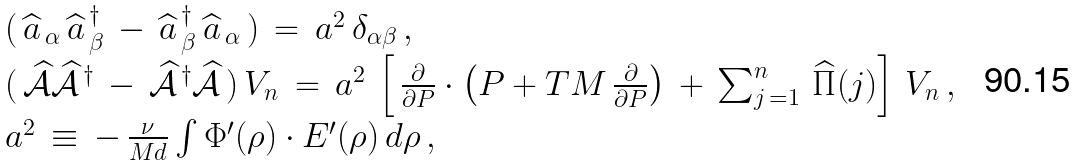Convert formula to latex. <formula><loc_0><loc_0><loc_500><loc_500>\begin{array} { l } ( \, \widehat { a } _ { \, \alpha } \, \widehat { a } ^ { \, \dag } _ { \, \beta } \, - \, \widehat { a } ^ { \, \dag } _ { \, \beta } \, \widehat { a } _ { \, \alpha } \, ) \, = \, a ^ { 2 } \, \delta _ { \alpha \beta } \, , \\ ( \, \widehat { \mathcal { A } } \widehat { \mathcal { A } } ^ { \, \dag } \, - \, \widehat { \mathcal { A } } ^ { \, \dag } \widehat { \mathcal { A } } \, ) \, V _ { n } \, = \, a ^ { 2 } \, \left [ \, \frac { \partial } { \partial { P } } \cdot \left ( { P } + T M \, \frac { \partial } { \partial { P } } \right ) \, + \, \sum _ { j \, = 1 } ^ { n } \, \widehat { \Pi } ( j ) \right ] \, V _ { n } \, , \\ a ^ { 2 } \, \equiv \, - \, \frac { \nu } { M d } \int \Phi ^ { \prime } ( \rho ) \cdot E ^ { \prime } ( \rho ) \, d \rho \, , \end{array}</formula> 